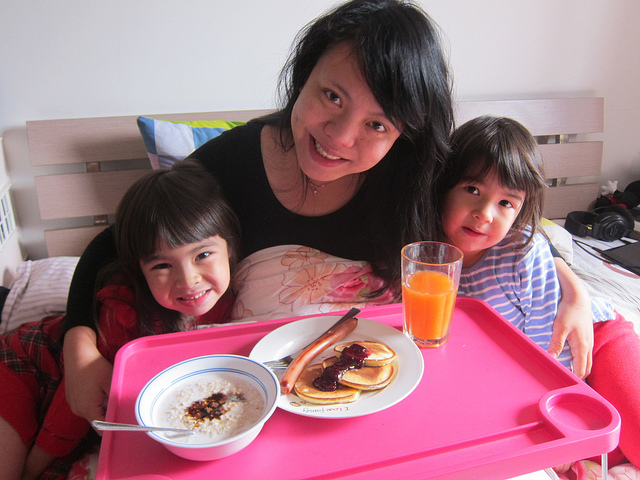How do these people know each other?
A. coworkers
B. family
C. classmates
D. teammates
Answer with the option's letter from the given choices directly. B. The individuals appear to be a family, as suggested by the domestic setting and their close physical proximity, which implies a level of familiarity and comfort typical of family members. They are sharing a meal in a home environment, which commonly indicates a familial relationship. 